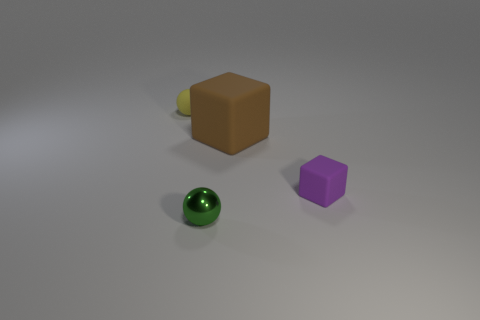Add 4 tiny purple rubber things. How many objects exist? 8 Subtract all gray balls. Subtract all purple things. How many objects are left? 3 Add 2 tiny yellow balls. How many tiny yellow balls are left? 3 Add 4 small blocks. How many small blocks exist? 5 Subtract 0 brown spheres. How many objects are left? 4 